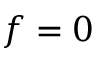Convert formula to latex. <formula><loc_0><loc_0><loc_500><loc_500>f = 0</formula> 